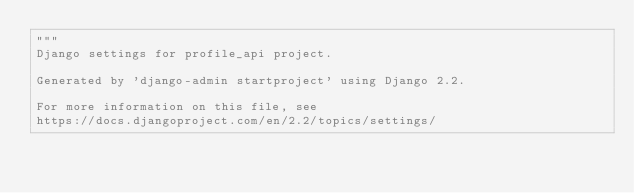Convert code to text. <code><loc_0><loc_0><loc_500><loc_500><_Python_>"""
Django settings for profile_api project.

Generated by 'django-admin startproject' using Django 2.2.

For more information on this file, see
https://docs.djangoproject.com/en/2.2/topics/settings/
</code> 